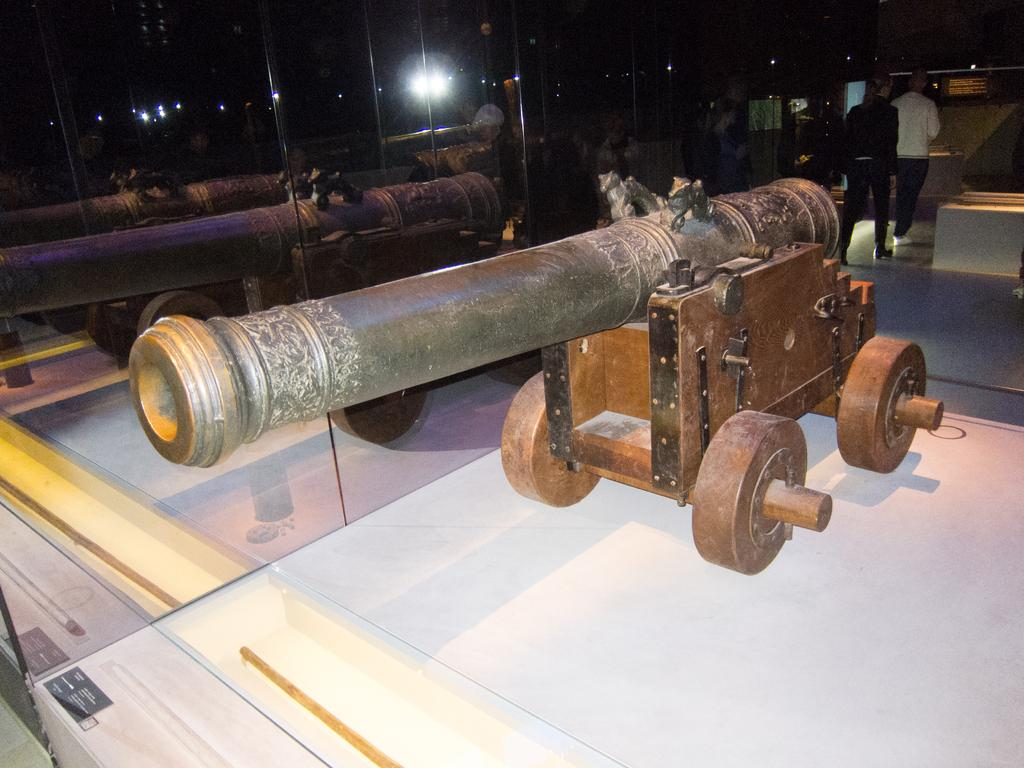What is the main object in the center of the image? There is a canon in the center of the image. How is the canon positioned in the image? The canon is placed on a surface. What other objects can be seen in the image? There is a mirror and lights in the image. How many people are present in the image? There are two people standing on the floor in the image. What type of curve can be seen in the image? There is no curve present in the image. How many pizzas are being served in the image? There are no pizzas present in the image. 